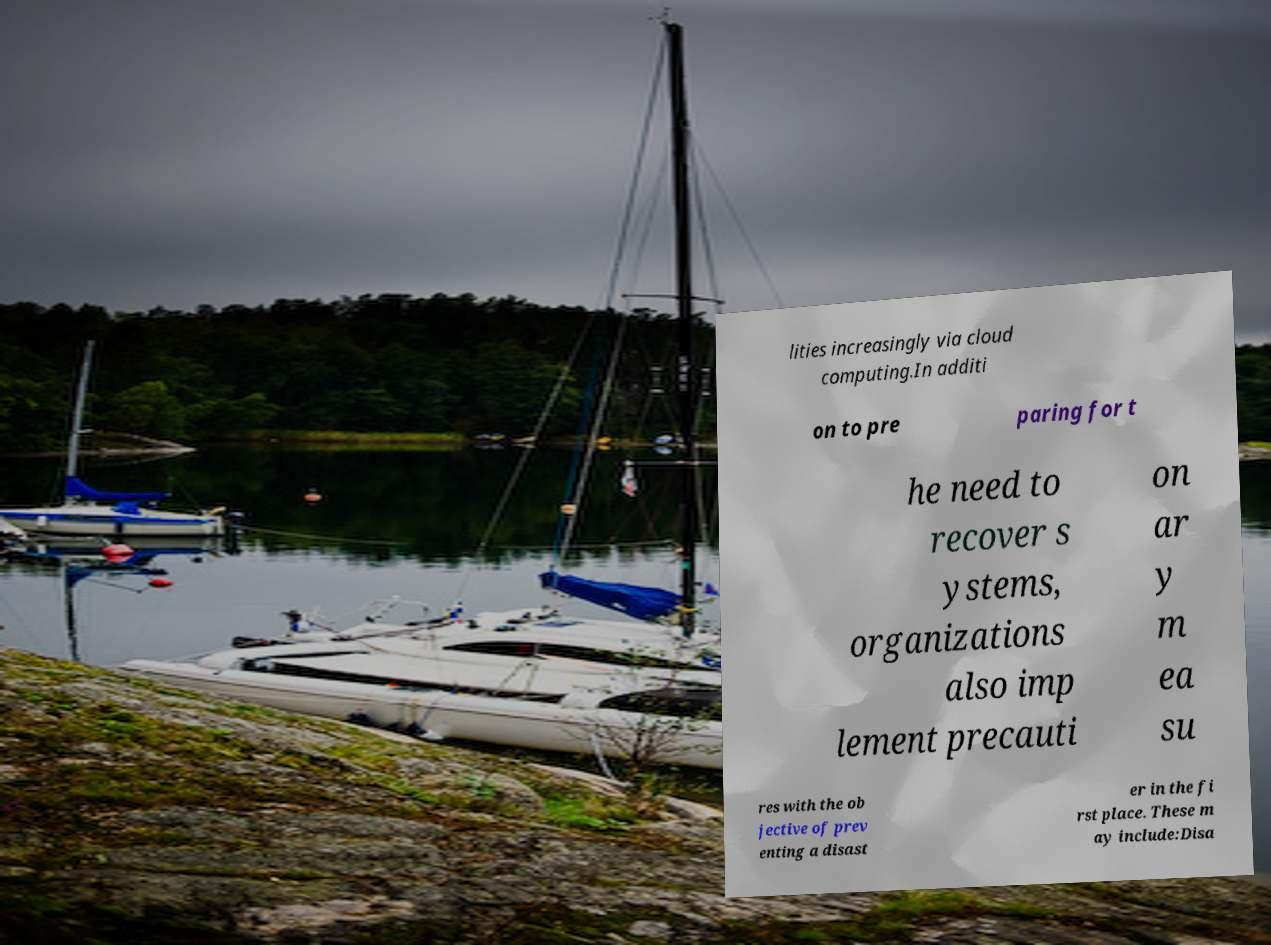Can you read and provide the text displayed in the image?This photo seems to have some interesting text. Can you extract and type it out for me? lities increasingly via cloud computing.In additi on to pre paring for t he need to recover s ystems, organizations also imp lement precauti on ar y m ea su res with the ob jective of prev enting a disast er in the fi rst place. These m ay include:Disa 